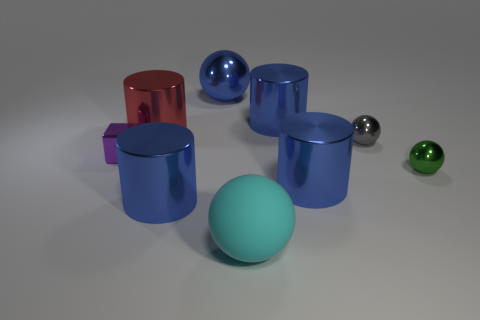Do the blue cylinder that is to the left of the cyan thing and the small green object that is on the right side of the metallic block have the same material?
Offer a terse response. Yes. What number of yellow things are either large cylinders or rubber spheres?
Offer a terse response. 0. How big is the green metallic thing?
Ensure brevity in your answer.  Small. Are there more large blue metallic things that are to the right of the large cyan rubber ball than purple matte objects?
Offer a very short reply. Yes. There is a purple metal thing; how many large red things are on the left side of it?
Offer a terse response. 0. Is there a rubber thing that has the same size as the shiny block?
Your answer should be compact. No. What is the color of the other big metal object that is the same shape as the big cyan object?
Offer a terse response. Blue. There is a shiny sphere that is behind the red metallic cylinder; does it have the same size as the blue cylinder left of the cyan thing?
Give a very brief answer. Yes. Are there any other large metallic objects that have the same shape as the red metal thing?
Keep it short and to the point. Yes. Are there an equal number of small gray balls that are in front of the tiny purple metal cube and gray shiny spheres?
Keep it short and to the point. No. 